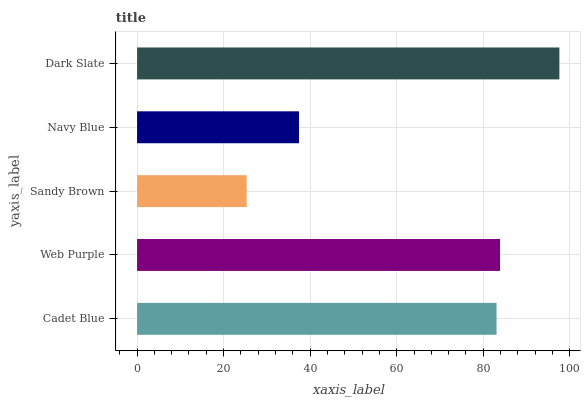Is Sandy Brown the minimum?
Answer yes or no. Yes. Is Dark Slate the maximum?
Answer yes or no. Yes. Is Web Purple the minimum?
Answer yes or no. No. Is Web Purple the maximum?
Answer yes or no. No. Is Web Purple greater than Cadet Blue?
Answer yes or no. Yes. Is Cadet Blue less than Web Purple?
Answer yes or no. Yes. Is Cadet Blue greater than Web Purple?
Answer yes or no. No. Is Web Purple less than Cadet Blue?
Answer yes or no. No. Is Cadet Blue the high median?
Answer yes or no. Yes. Is Cadet Blue the low median?
Answer yes or no. Yes. Is Dark Slate the high median?
Answer yes or no. No. Is Web Purple the low median?
Answer yes or no. No. 